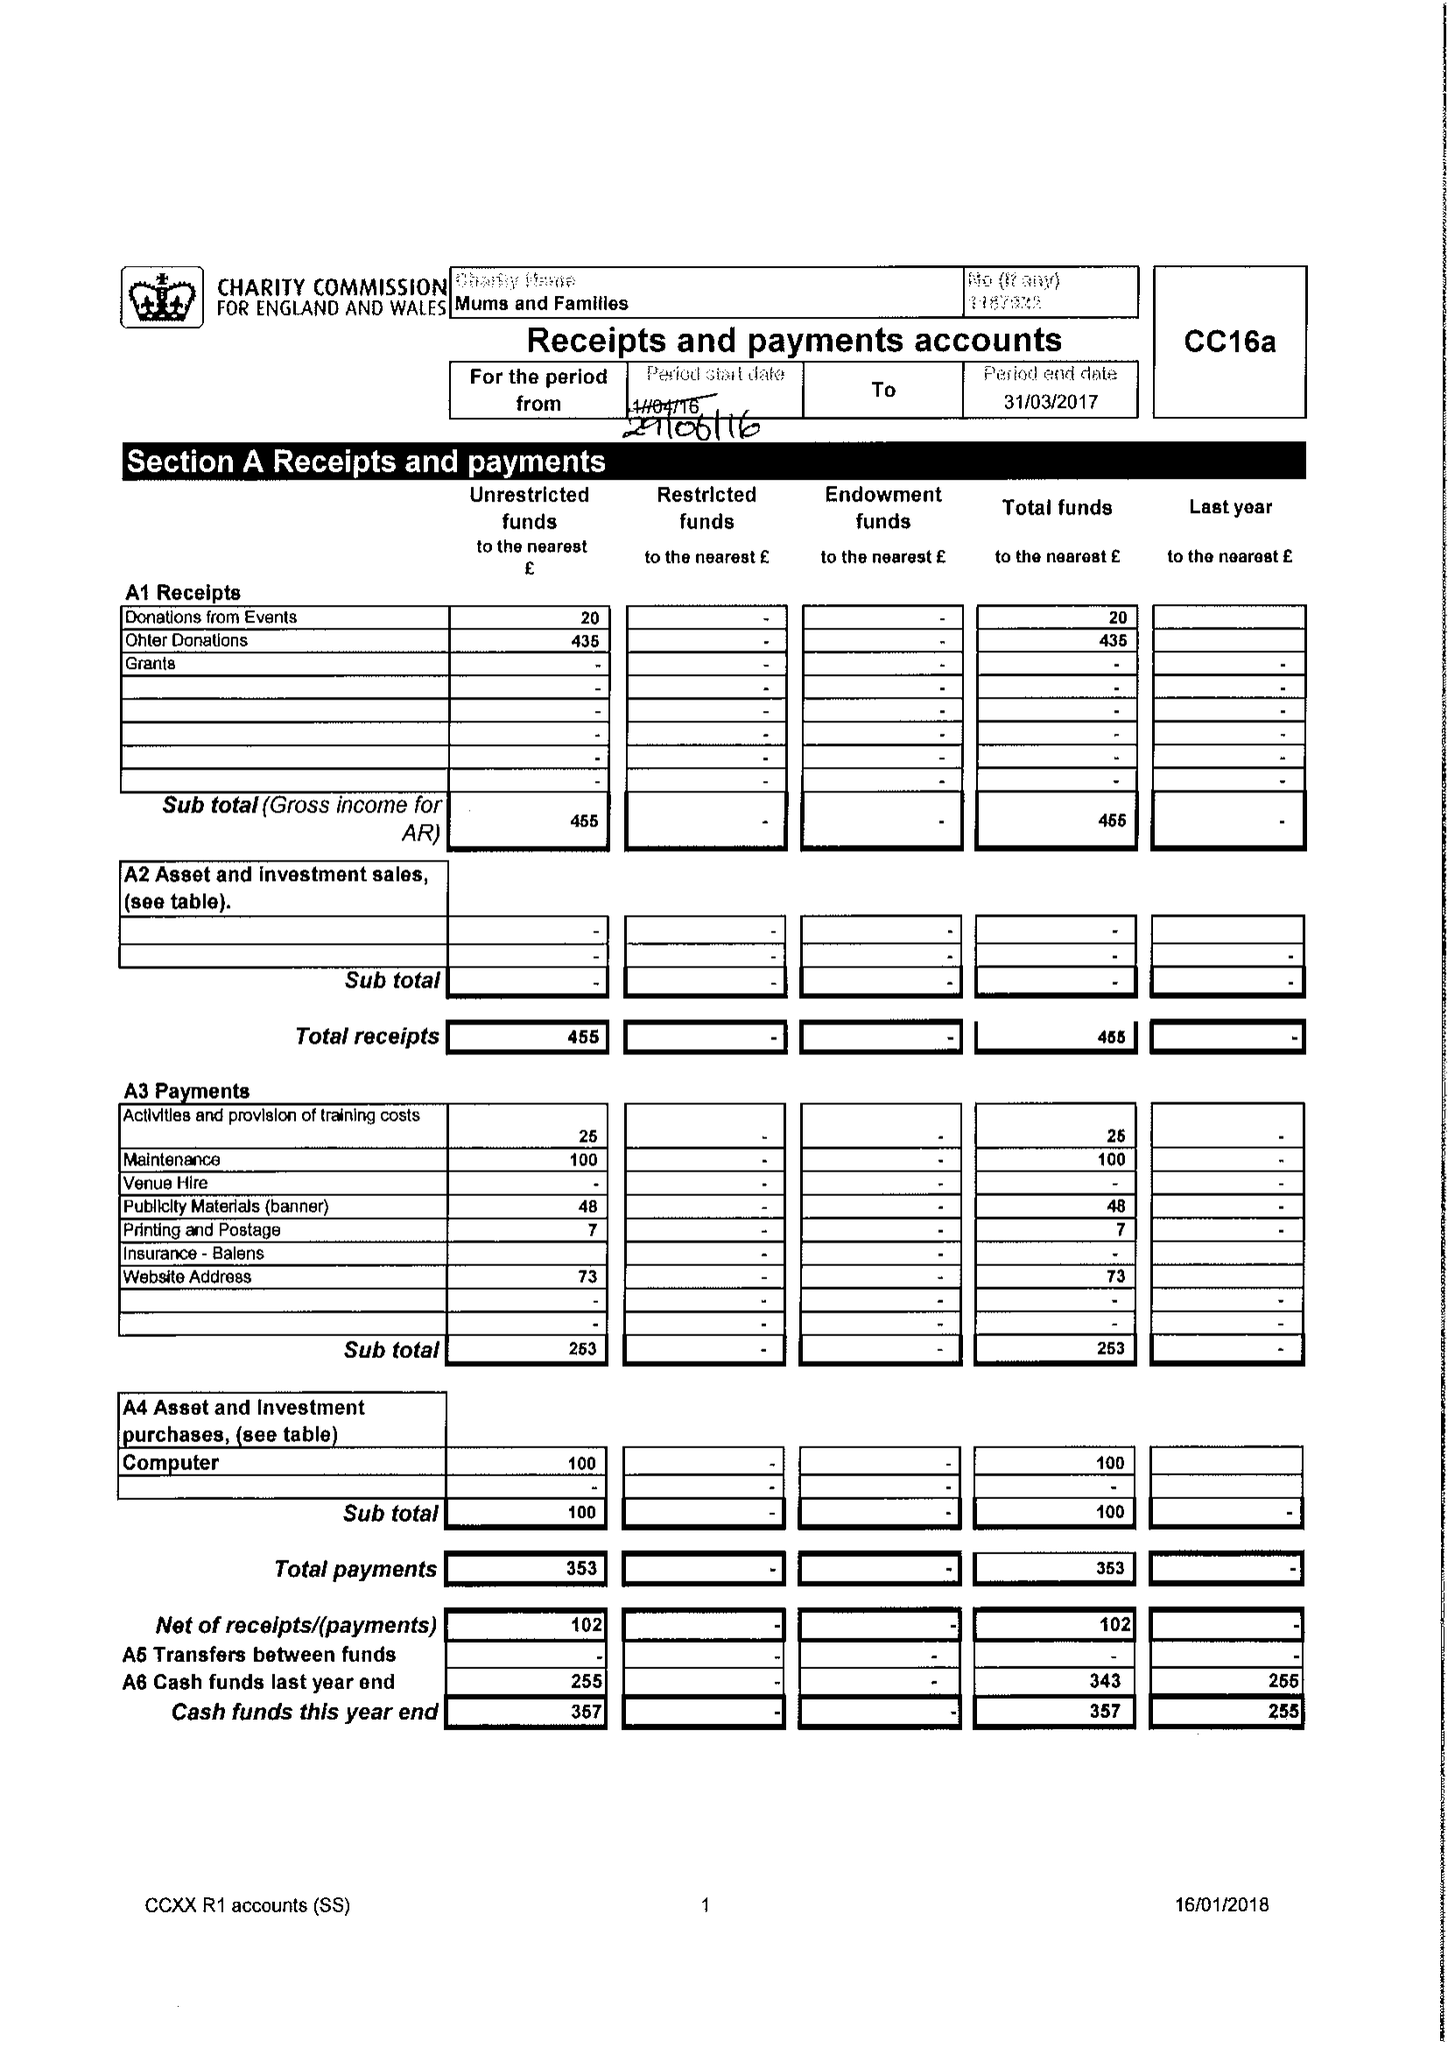What is the value for the address__postcode?
Answer the question using a single word or phrase. B13 9QE 